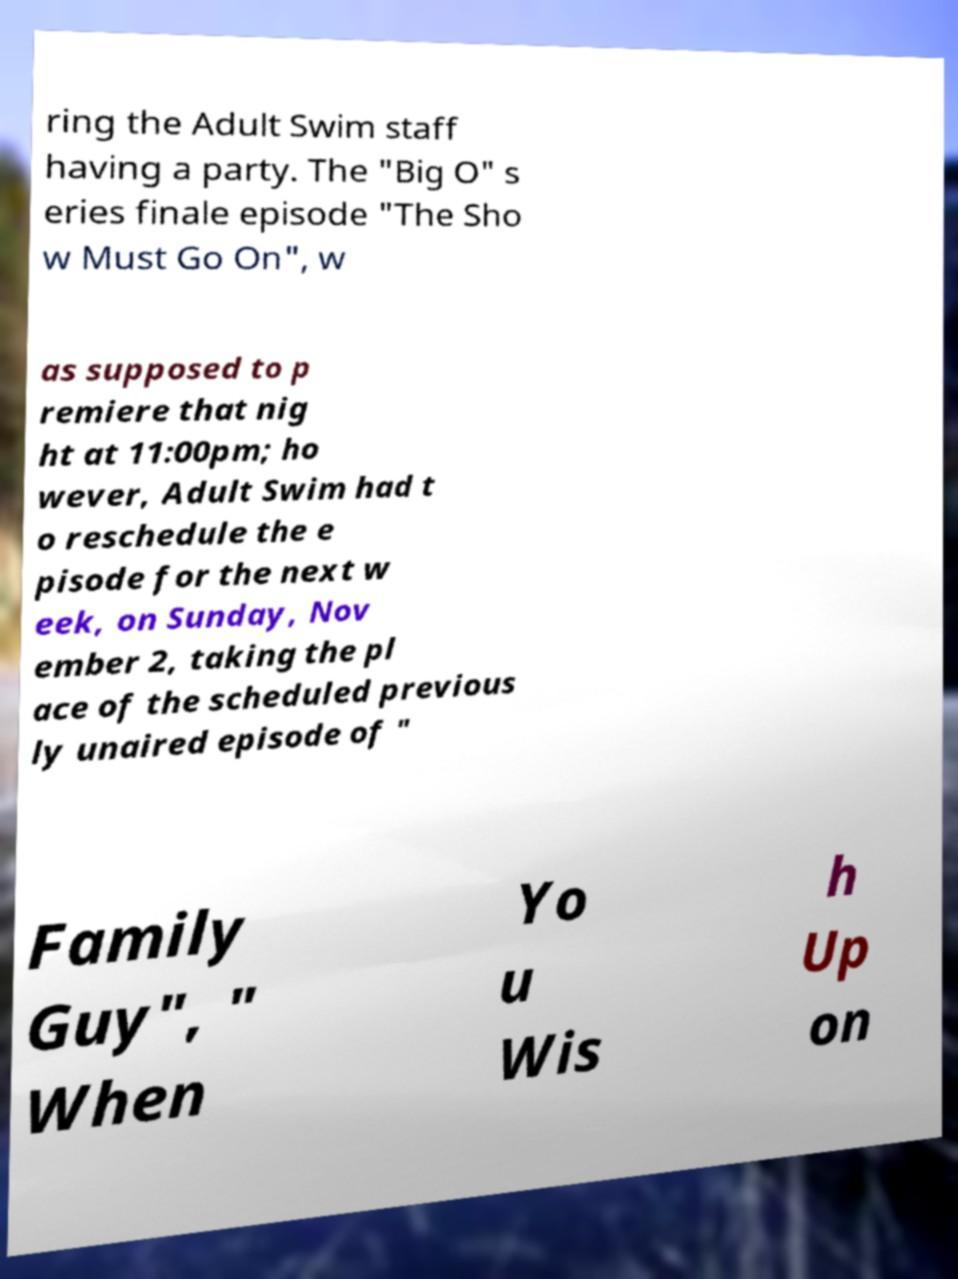Please identify and transcribe the text found in this image. ring the Adult Swim staff having a party. The "Big O" s eries finale episode "The Sho w Must Go On", w as supposed to p remiere that nig ht at 11:00pm; ho wever, Adult Swim had t o reschedule the e pisode for the next w eek, on Sunday, Nov ember 2, taking the pl ace of the scheduled previous ly unaired episode of " Family Guy", " When Yo u Wis h Up on 